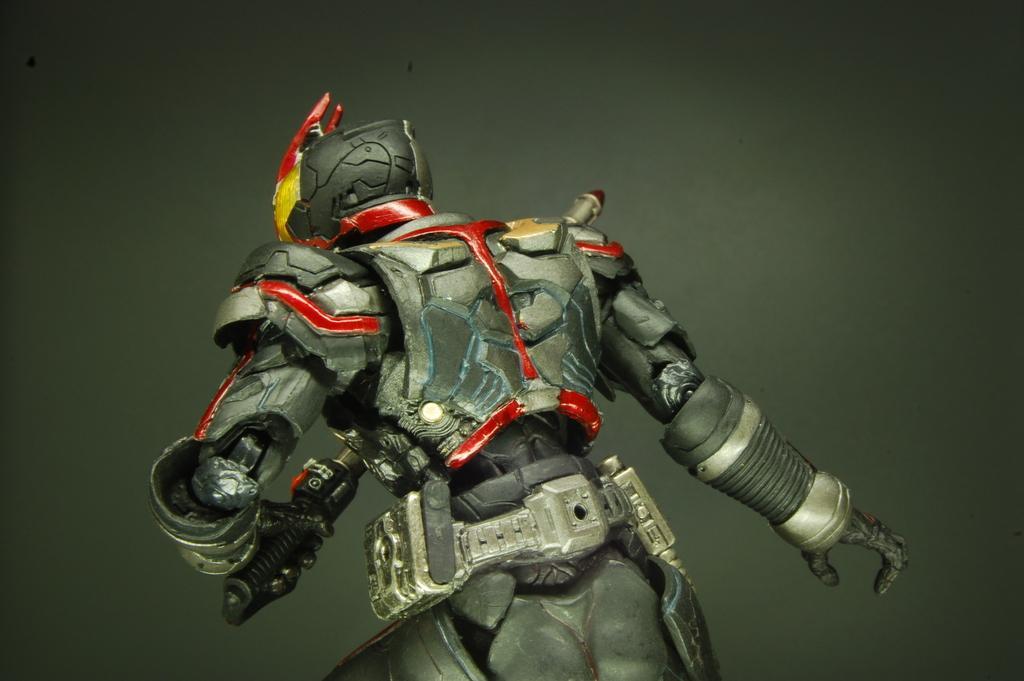How would you summarize this image in a sentence or two? This is an animated image. In this image I can see a robot. The background is in grey color. 